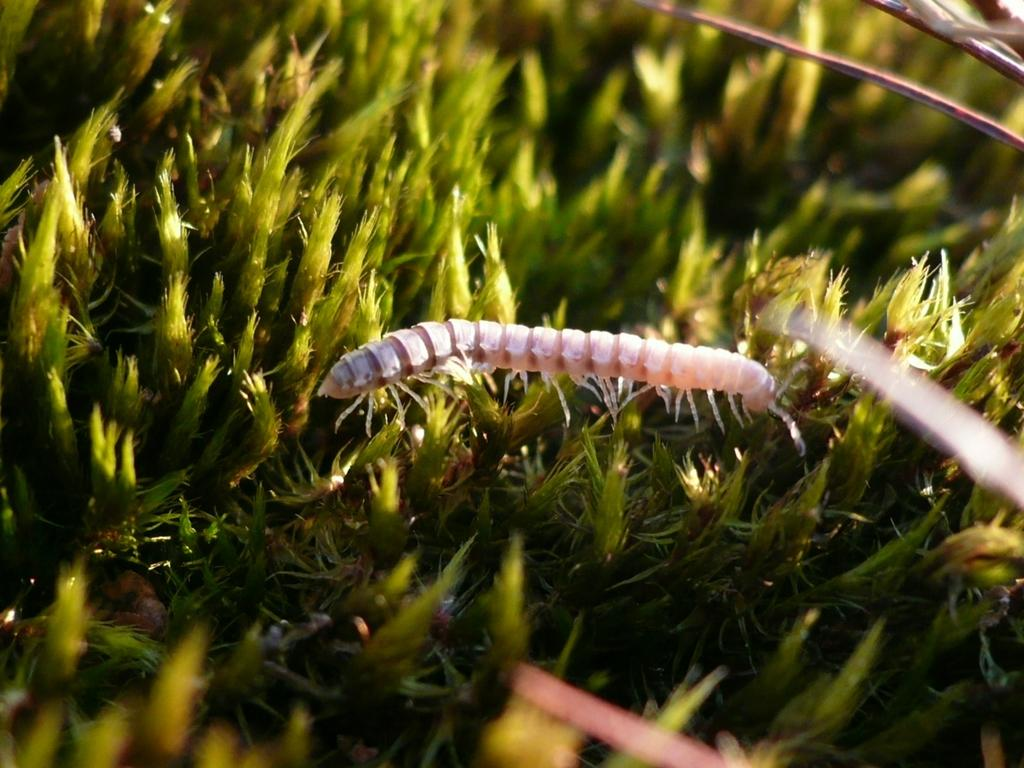What type of creature can be seen in the image? There is an insect in the image. Where is the insect located? The insect is on the grass. What color is the grass in the image? The grass in the image is green. What type of band is playing in the background of the image? There is no band present in the image; it features an insect on green grass. 